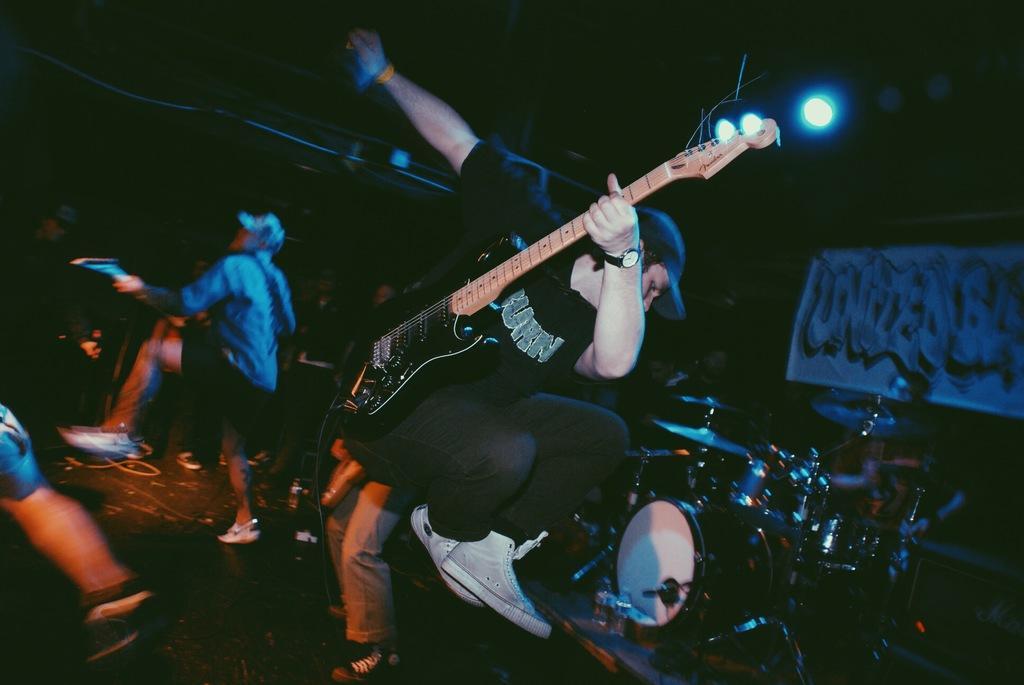How would you summarize this image in a sentence or two? In this picture there is a man who is jumping from the stage, by holding the guitar in his hand and there is a drum set at the right side of the image, there are other people those who are playing the music and some are dancing at the left side of the image and there are spotlights above the area of the image. 